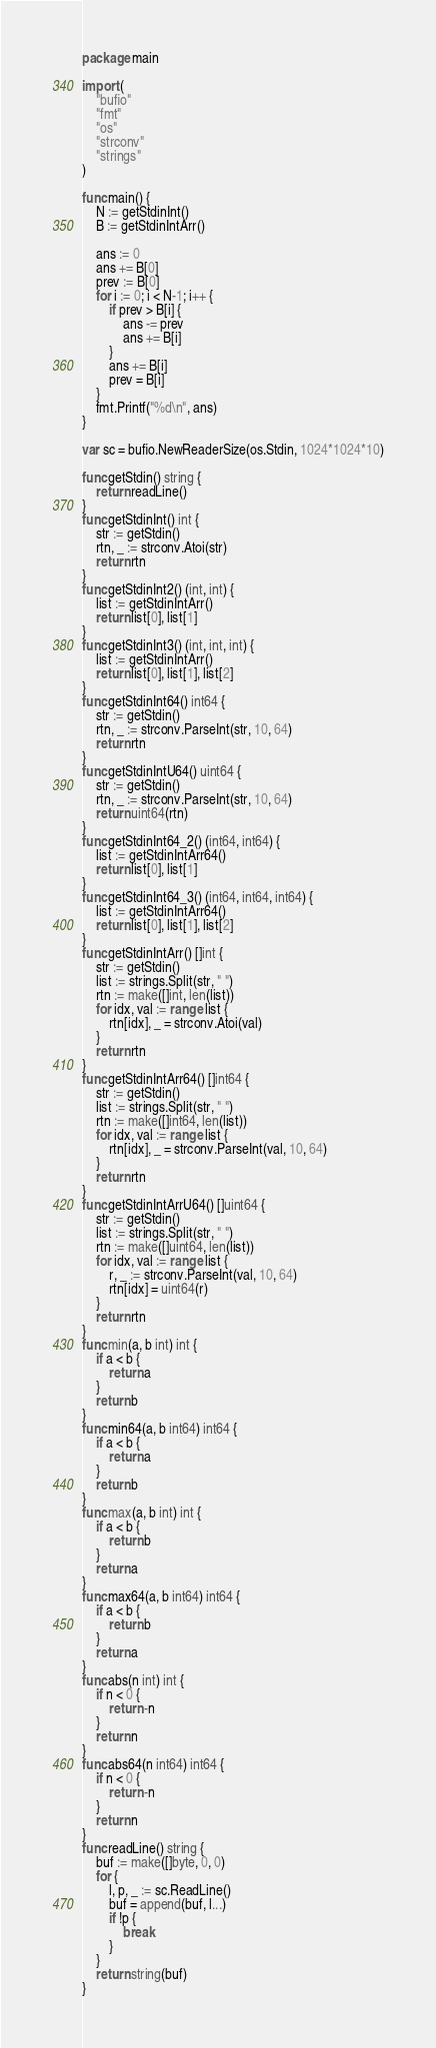Convert code to text. <code><loc_0><loc_0><loc_500><loc_500><_Go_>package main

import (
	"bufio"
	"fmt"
	"os"
	"strconv"
	"strings"
)

func main() {
	N := getStdinInt()
	B := getStdinIntArr()

	ans := 0
	ans += B[0]
	prev := B[0]
	for i := 0; i < N-1; i++ {
		if prev > B[i] {
			ans -= prev
			ans += B[i]
		}
		ans += B[i]
		prev = B[i]
	}
	fmt.Printf("%d\n", ans)
}

var sc = bufio.NewReaderSize(os.Stdin, 1024*1024*10)

func getStdin() string {
	return readLine()
}
func getStdinInt() int {
	str := getStdin()
	rtn, _ := strconv.Atoi(str)
	return rtn
}
func getStdinInt2() (int, int) {
	list := getStdinIntArr()
	return list[0], list[1]
}
func getStdinInt3() (int, int, int) {
	list := getStdinIntArr()
	return list[0], list[1], list[2]
}
func getStdinInt64() int64 {
	str := getStdin()
	rtn, _ := strconv.ParseInt(str, 10, 64)
	return rtn
}
func getStdinIntU64() uint64 {
	str := getStdin()
	rtn, _ := strconv.ParseInt(str, 10, 64)
	return uint64(rtn)
}
func getStdinInt64_2() (int64, int64) {
	list := getStdinIntArr64()
	return list[0], list[1]
}
func getStdinInt64_3() (int64, int64, int64) {
	list := getStdinIntArr64()
	return list[0], list[1], list[2]
}
func getStdinIntArr() []int {
	str := getStdin()
	list := strings.Split(str, " ")
	rtn := make([]int, len(list))
	for idx, val := range list {
		rtn[idx], _ = strconv.Atoi(val)
	}
	return rtn
}
func getStdinIntArr64() []int64 {
	str := getStdin()
	list := strings.Split(str, " ")
	rtn := make([]int64, len(list))
	for idx, val := range list {
		rtn[idx], _ = strconv.ParseInt(val, 10, 64)
	}
	return rtn
}
func getStdinIntArrU64() []uint64 {
	str := getStdin()
	list := strings.Split(str, " ")
	rtn := make([]uint64, len(list))
	for idx, val := range list {
		r, _ := strconv.ParseInt(val, 10, 64)
		rtn[idx] = uint64(r)
	}
	return rtn
}
func min(a, b int) int {
	if a < b {
		return a
	}
	return b
}
func min64(a, b int64) int64 {
	if a < b {
		return a
	}
	return b
}
func max(a, b int) int {
	if a < b {
		return b
	}
	return a
}
func max64(a, b int64) int64 {
	if a < b {
		return b
	}
	return a
}
func abs(n int) int {
	if n < 0 {
		return -n
	}
	return n
}
func abs64(n int64) int64 {
	if n < 0 {
		return -n
	}
	return n
}
func readLine() string {
	buf := make([]byte, 0, 0)
	for {
		l, p, _ := sc.ReadLine()
		buf = append(buf, l...)
		if !p {
			break
		}
	}
	return string(buf)
}
</code> 